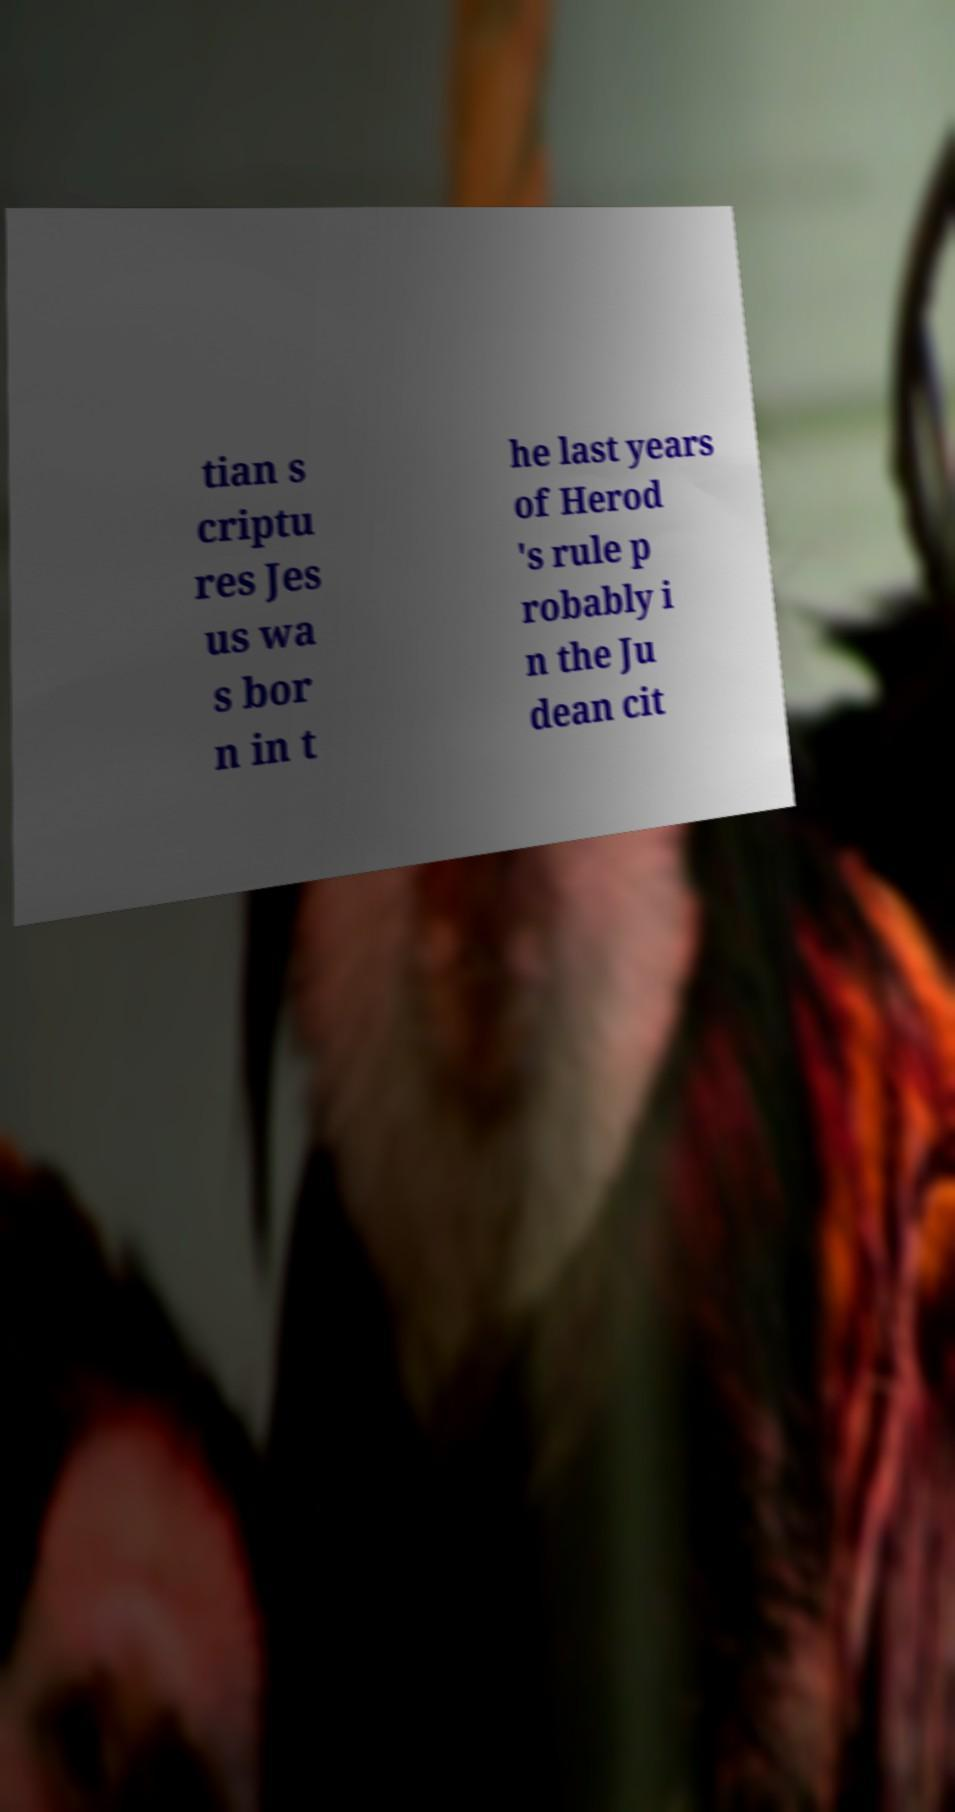Please identify and transcribe the text found in this image. tian s criptu res Jes us wa s bor n in t he last years of Herod 's rule p robably i n the Ju dean cit 